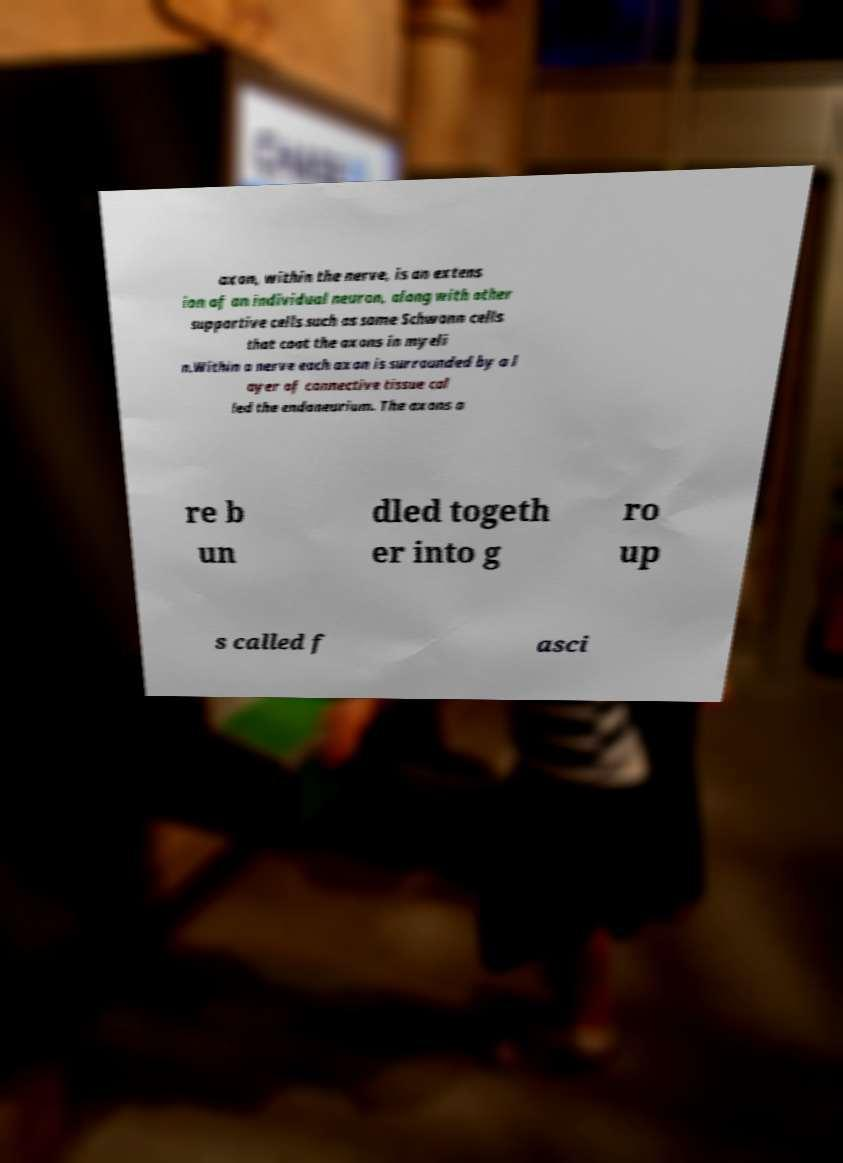I need the written content from this picture converted into text. Can you do that? axon, within the nerve, is an extens ion of an individual neuron, along with other supportive cells such as some Schwann cells that coat the axons in myeli n.Within a nerve each axon is surrounded by a l ayer of connective tissue cal led the endoneurium. The axons a re b un dled togeth er into g ro up s called f asci 